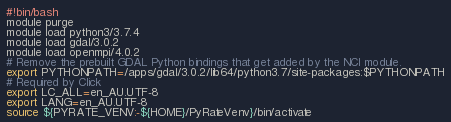Convert code to text. <code><loc_0><loc_0><loc_500><loc_500><_Bash_>#!bin/bash
module purge
module load python3/3.7.4
module load gdal/3.0.2
module load openmpi/4.0.2
# Remove the prebuilt GDAL Python bindings that get added by the NCI module.
export PYTHONPATH=/apps/gdal/3.0.2/lib64/python3.7/site-packages:$PYTHONPATH
# Required by Click
export LC_ALL=en_AU.UTF-8
export LANG=en_AU.UTF-8
source ${PYRATE_VENV:-${HOME}/PyRateVenv}/bin/activate
</code> 